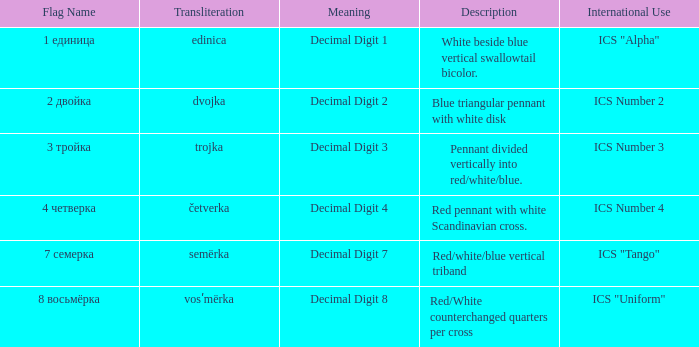What do the symbols on the flag, which is transliterated as "semërka," represent? Decimal Digit 7. 